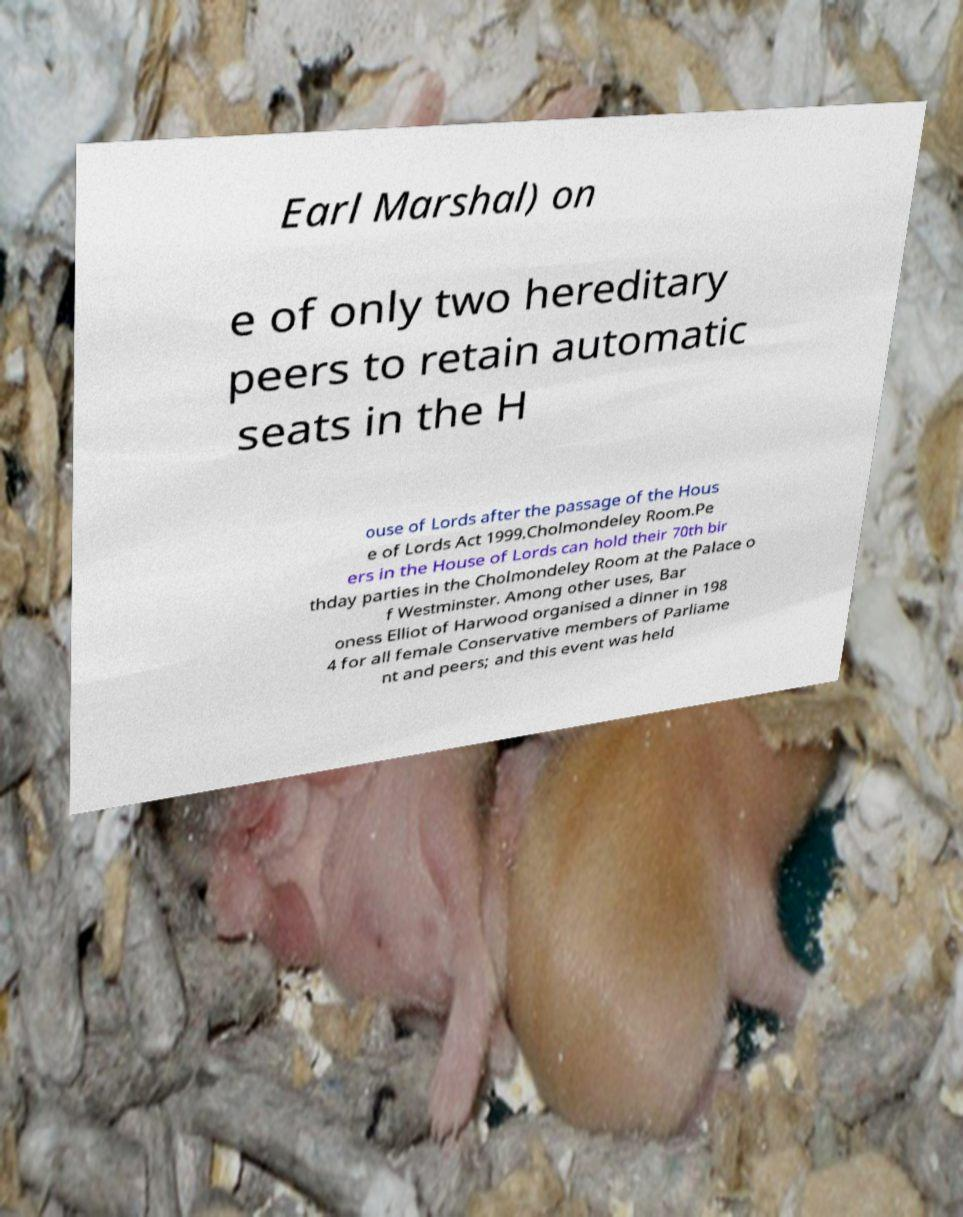Could you extract and type out the text from this image? Earl Marshal) on e of only two hereditary peers to retain automatic seats in the H ouse of Lords after the passage of the Hous e of Lords Act 1999.Cholmondeley Room.Pe ers in the House of Lords can hold their 70th bir thday parties in the Cholmondeley Room at the Palace o f Westminster. Among other uses, Bar oness Elliot of Harwood organised a dinner in 198 4 for all female Conservative members of Parliame nt and peers; and this event was held 